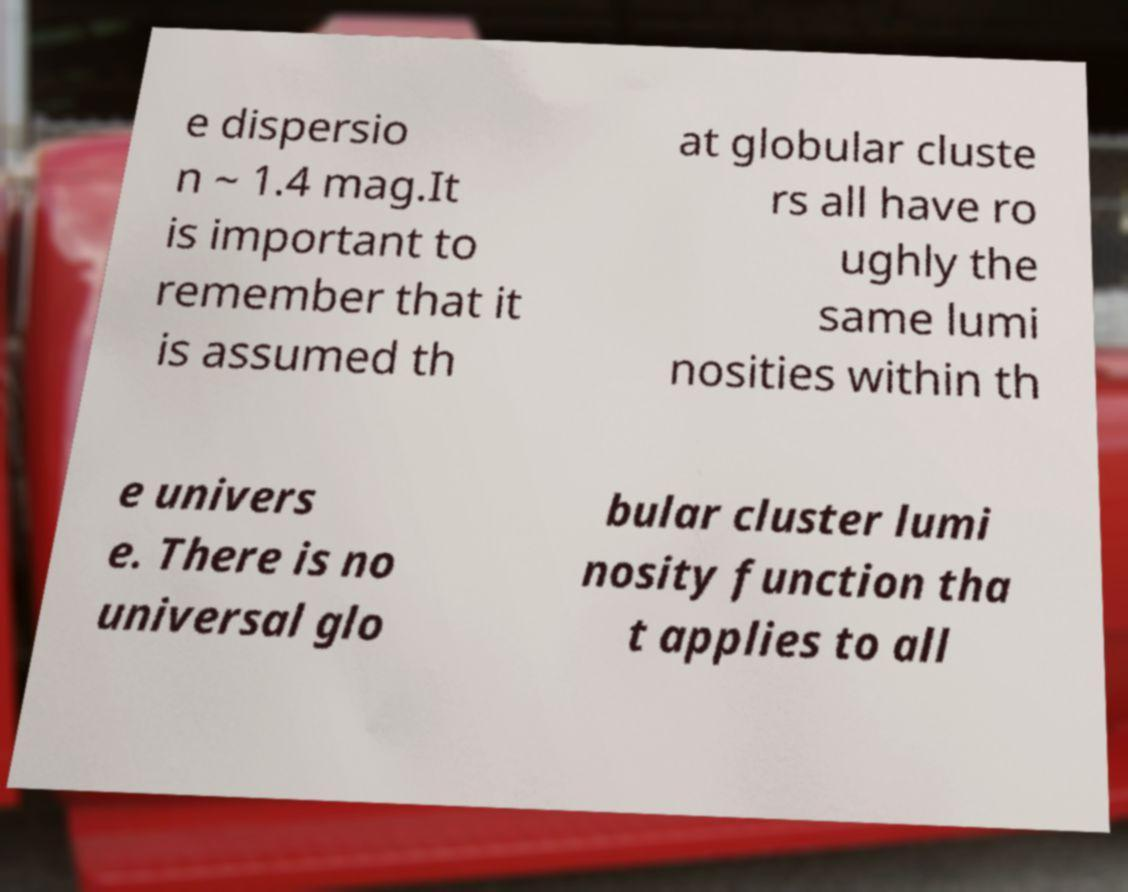There's text embedded in this image that I need extracted. Can you transcribe it verbatim? e dispersio n ~ 1.4 mag.It is important to remember that it is assumed th at globular cluste rs all have ro ughly the same lumi nosities within th e univers e. There is no universal glo bular cluster lumi nosity function tha t applies to all 